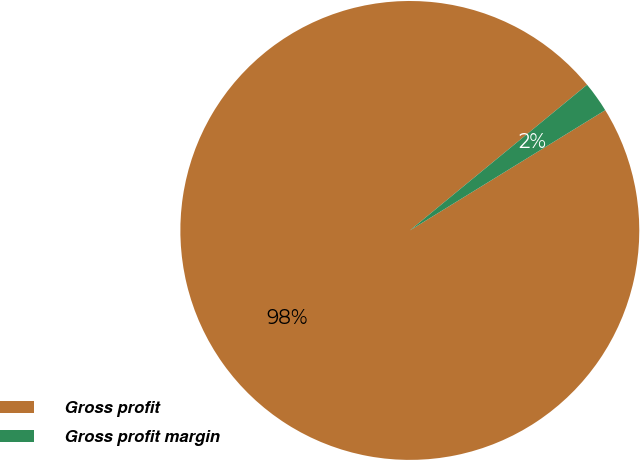Convert chart. <chart><loc_0><loc_0><loc_500><loc_500><pie_chart><fcel>Gross profit<fcel>Gross profit margin<nl><fcel>97.83%<fcel>2.17%<nl></chart> 